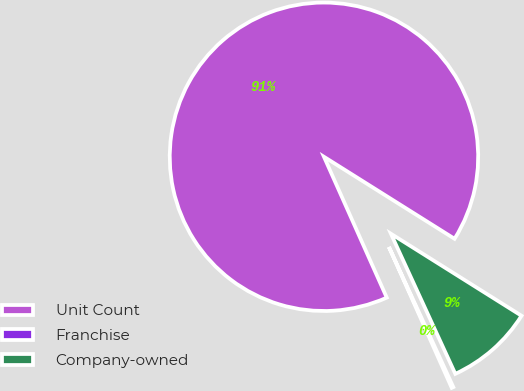Convert chart. <chart><loc_0><loc_0><loc_500><loc_500><pie_chart><fcel>Unit Count<fcel>Franchise<fcel>Company-owned<nl><fcel>90.6%<fcel>0.18%<fcel>9.22%<nl></chart> 